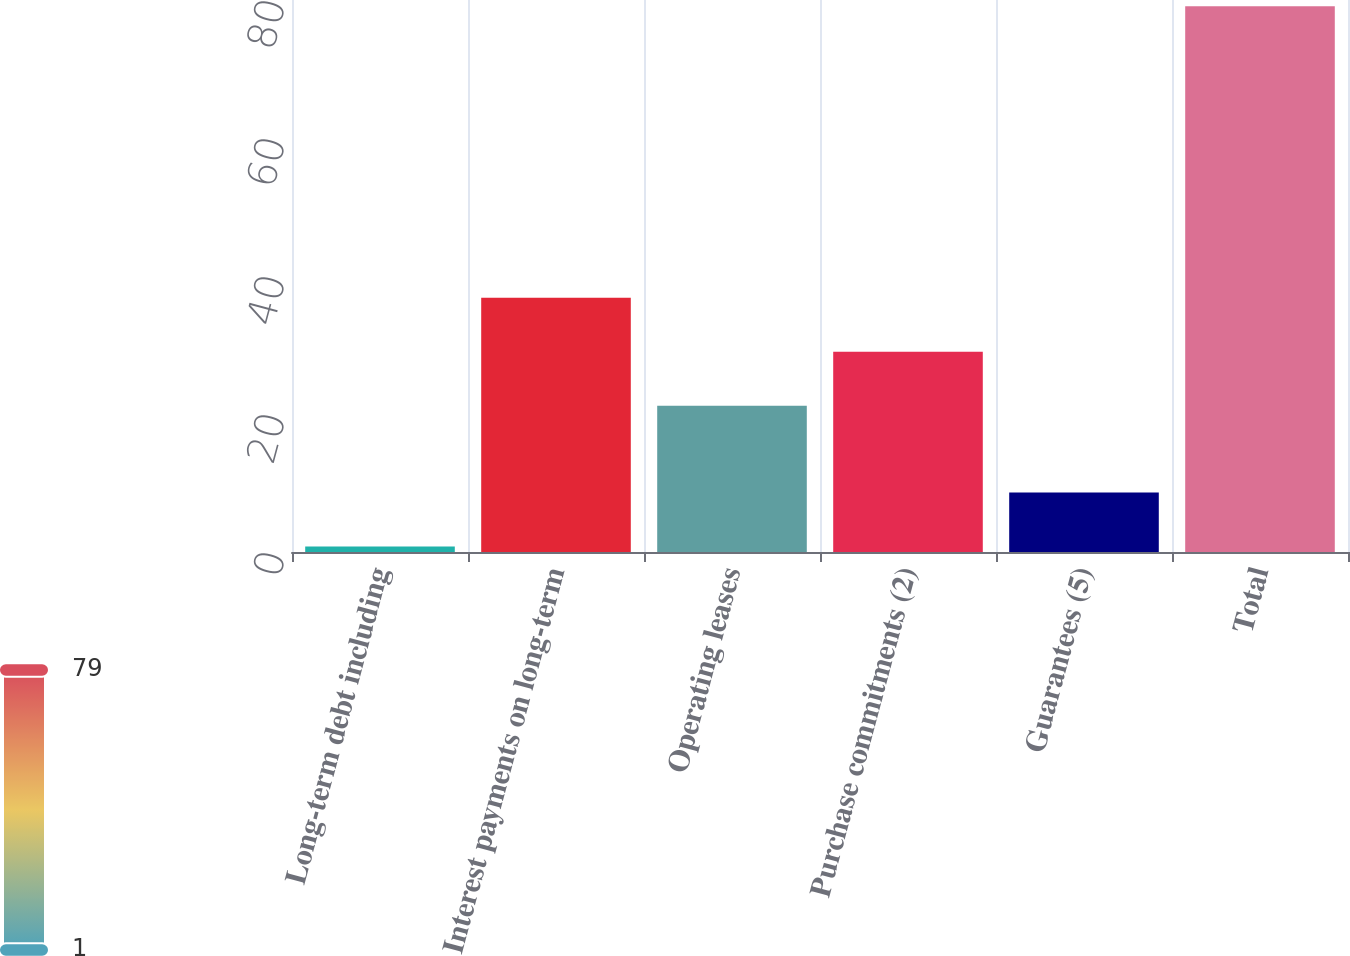Convert chart. <chart><loc_0><loc_0><loc_500><loc_500><bar_chart><fcel>Long-term debt including<fcel>Interest payments on long-term<fcel>Operating leases<fcel>Purchase commitments (2)<fcel>Guarantees (5)<fcel>Total<nl><fcel>0.8<fcel>36.86<fcel>21.2<fcel>29.03<fcel>8.63<fcel>79.1<nl></chart> 